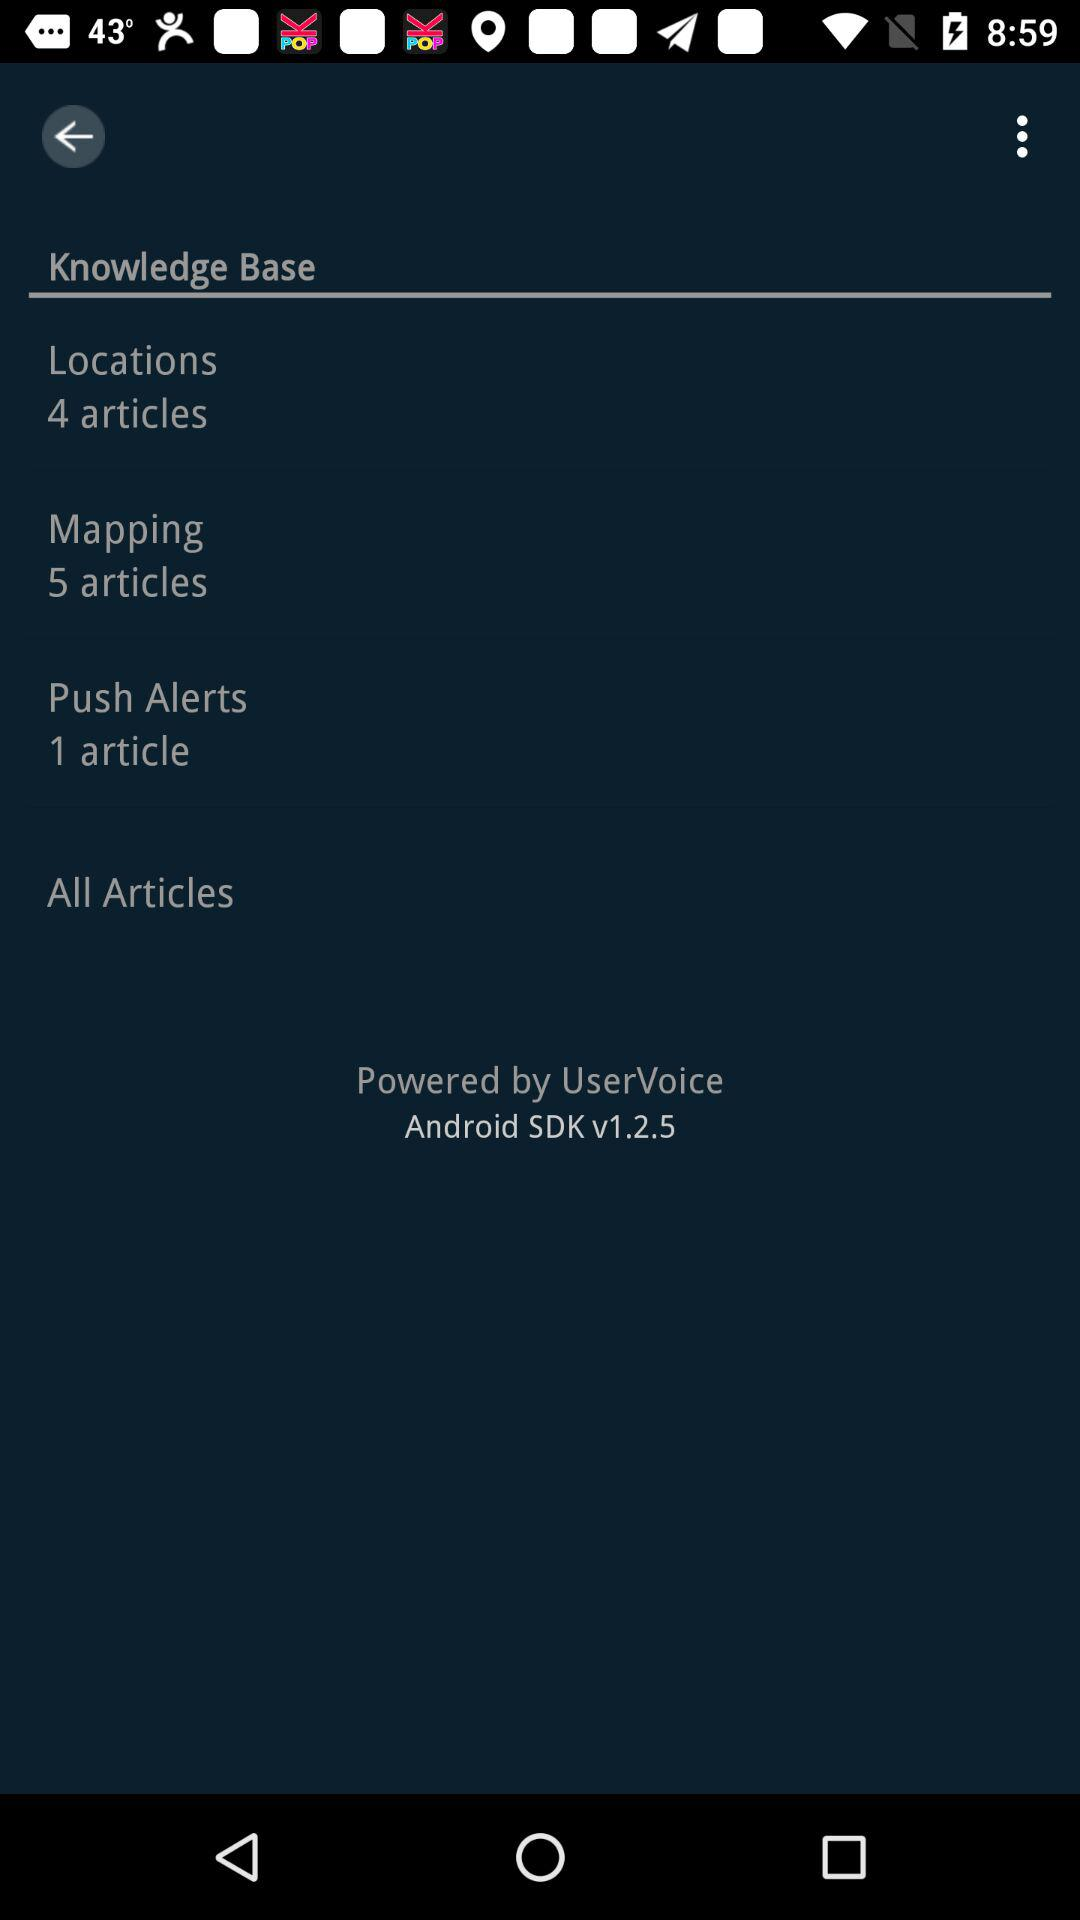How many articles are there in all sections combined?
Answer the question using a single word or phrase. 10 